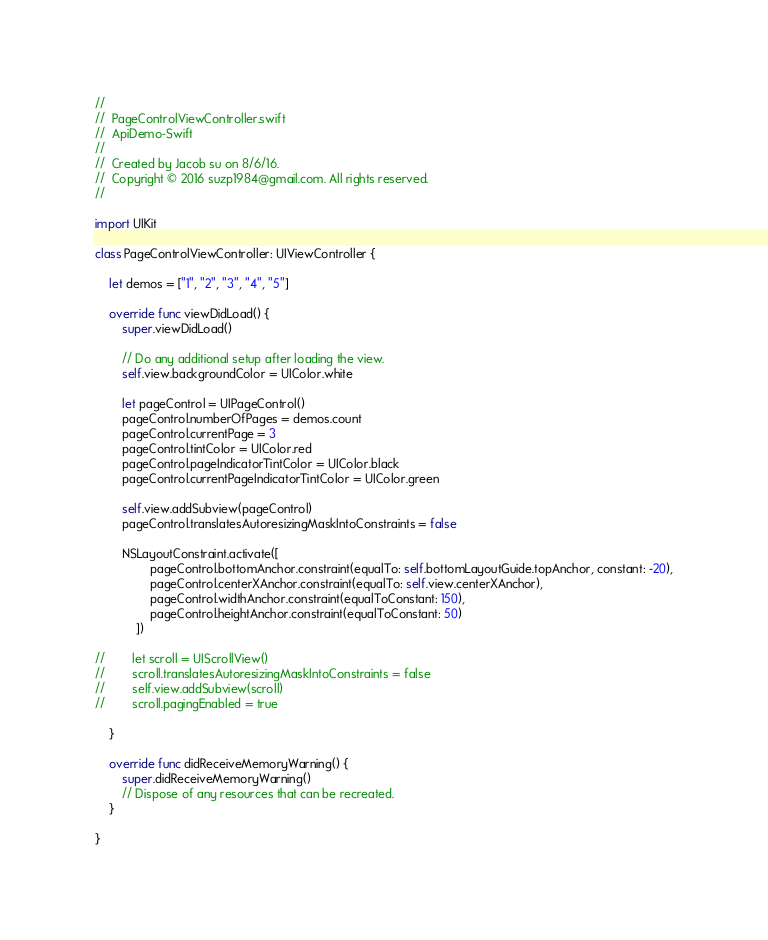<code> <loc_0><loc_0><loc_500><loc_500><_Swift_>//
//  PageControlViewController.swift
//  ApiDemo-Swift
//
//  Created by Jacob su on 8/6/16.
//  Copyright © 2016 suzp1984@gmail.com. All rights reserved.
//

import UIKit

class PageControlViewController: UIViewController {

    let demos = ["1", "2", "3", "4", "5"]
    
    override func viewDidLoad() {
        super.viewDidLoad()

        // Do any additional setup after loading the view.
        self.view.backgroundColor = UIColor.white
        
        let pageControl = UIPageControl()
        pageControl.numberOfPages = demos.count
        pageControl.currentPage = 3
        pageControl.tintColor = UIColor.red
        pageControl.pageIndicatorTintColor = UIColor.black
        pageControl.currentPageIndicatorTintColor = UIColor.green
        
        self.view.addSubview(pageControl)
        pageControl.translatesAutoresizingMaskIntoConstraints = false
        
        NSLayoutConstraint.activate([
                pageControl.bottomAnchor.constraint(equalTo: self.bottomLayoutGuide.topAnchor, constant: -20),
                pageControl.centerXAnchor.constraint(equalTo: self.view.centerXAnchor),
                pageControl.widthAnchor.constraint(equalToConstant: 150),
                pageControl.heightAnchor.constraint(equalToConstant: 50)
            ])
        
//        let scroll = UIScrollView()
//        scroll.translatesAutoresizingMaskIntoConstraints = false
//        self.view.addSubview(scroll)
//        scroll.pagingEnabled = true
        
    }

    override func didReceiveMemoryWarning() {
        super.didReceiveMemoryWarning()
        // Dispose of any resources that can be recreated.
    }

}
</code> 